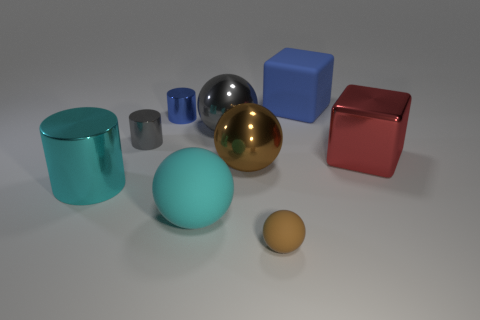Subtract all tiny brown balls. How many balls are left? 3 Subtract all gray cubes. How many brown balls are left? 2 Subtract 2 spheres. How many spheres are left? 2 Subtract all gray spheres. How many spheres are left? 3 Add 1 purple things. How many objects exist? 10 Subtract all yellow balls. Subtract all cyan cylinders. How many balls are left? 4 Add 3 red things. How many red things exist? 4 Subtract 0 yellow cylinders. How many objects are left? 9 Subtract all cubes. How many objects are left? 7 Subtract all small blue metal things. Subtract all cyan spheres. How many objects are left? 7 